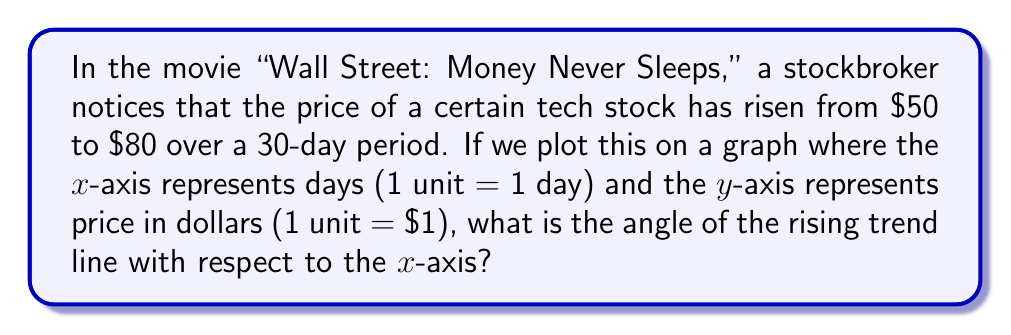Show me your answer to this math problem. Let's approach this step-by-step:

1) First, we need to identify the rise and run of the trend line:
   Rise = Change in price = $80 - $50 = $30
   Run = Number of days = 30 days

2) The angle of the trend line can be calculated using the arctangent function:
   $$\theta = \arctan(\frac{\text{rise}}{\text{run}})$$

3) Substituting our values:
   $$\theta = \arctan(\frac{30}{30})$$

4) Simplify:
   $$\theta = \arctan(1)$$

5) The arctangent of 1 is 45 degrees or $\frac{\pi}{4}$ radians.

[asy]
import geometry;

size(200);
real angle = radians(45);
pair A = (0,0), B = (5,0), C = (5,5);
draw(A--B--C--A);
draw(arc(B,0.5,0,angle),Arrow);
label("$45^\circ$", B+(0.7,0.3));
label("30 days", (2.5,-0.5));
label("$30", (5.5,2.5));

[/asy]
Answer: $45^\circ$ or $\frac{\pi}{4}$ radians 